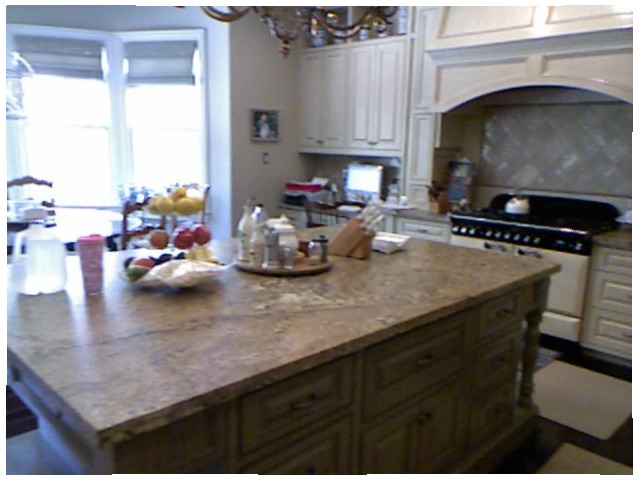<image>
Is there a chandelier above the island? Yes. The chandelier is positioned above the island in the vertical space, higher up in the scene. Is the bottle to the left of the cup? Yes. From this viewpoint, the bottle is positioned to the left side relative to the cup. Where is the spice in relation to the shaker? Is it in the shaker? Yes. The spice is contained within or inside the shaker, showing a containment relationship. 